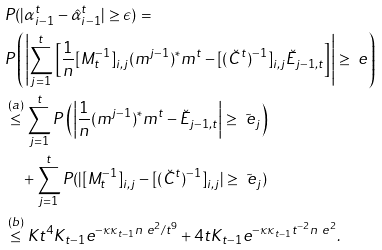Convert formula to latex. <formula><loc_0><loc_0><loc_500><loc_500>& P ( | \alpha ^ { t } _ { i - 1 } - \hat { \alpha } ^ { t } _ { i - 1 } | \geq \epsilon ) = \\ & P \left ( \left | \sum _ { j = 1 } ^ { t } \left [ \frac { 1 } { n } [ M _ { t } ^ { - 1 } ] _ { i , j } ( m ^ { j - 1 } ) ^ { * } m ^ { t } - [ ( \breve { C } ^ { t } ) ^ { - 1 } ] _ { i , j } \breve { E } _ { j - 1 , t } \right ] \right | \geq \ e \right ) \\ & \overset { ( a ) } { \leq } \sum _ { j = 1 } ^ { t } P \left ( \left | \frac { 1 } { n } ( m ^ { j - 1 } ) ^ { * } m ^ { t } - \breve { E } _ { j - 1 , t } \right | \geq \tilde { \ e } _ { j } \right ) \\ & \quad + \sum _ { j = 1 } ^ { t } P ( | [ M _ { t } ^ { - 1 } ] _ { i , j } - [ ( \breve { C } ^ { t } ) ^ { - 1 } ] _ { i , j } | \geq \tilde { \ e } _ { j } ) \\ & \overset { ( b ) } { \leq } K t ^ { 4 } K _ { t - 1 } e ^ { - \kappa \kappa _ { t - 1 } n \ e ^ { 2 } / t ^ { 9 } } + 4 t K _ { t - 1 } e ^ { - \kappa \kappa _ { t - 1 } t ^ { - 2 } n \ e ^ { 2 } } .</formula> 